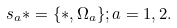<formula> <loc_0><loc_0><loc_500><loc_500>s _ { a } \ast = \{ \ast , \Omega _ { a } \} ; a = 1 , 2 .</formula> 